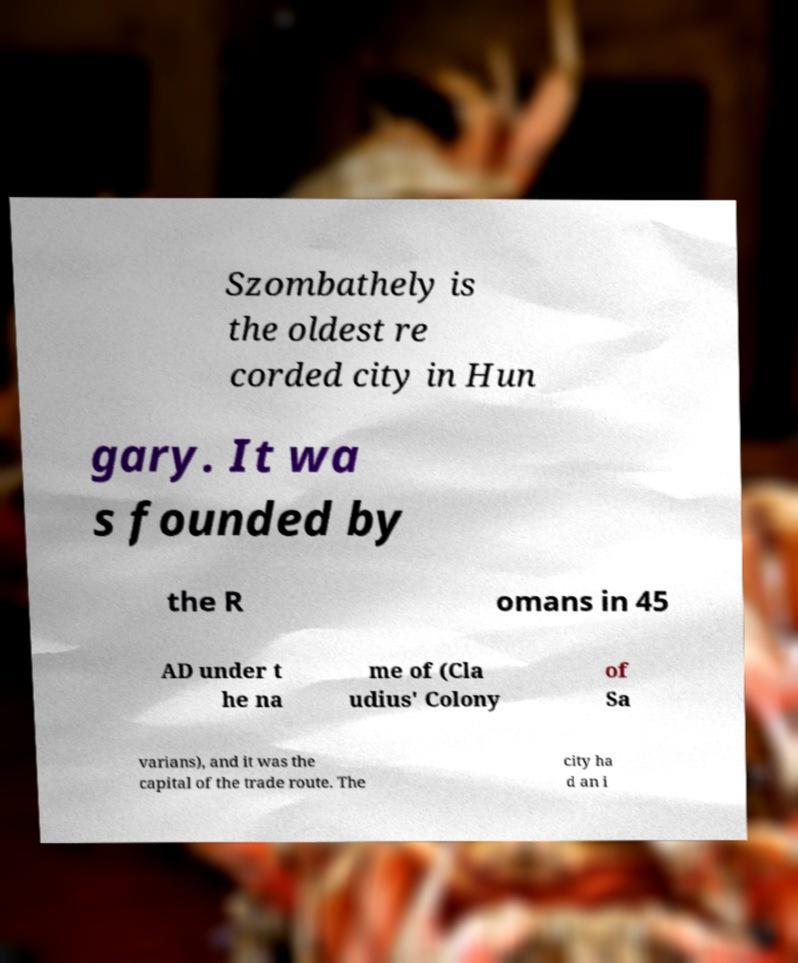Please read and relay the text visible in this image. What does it say? Szombathely is the oldest re corded city in Hun gary. It wa s founded by the R omans in 45 AD under t he na me of (Cla udius' Colony of Sa varians), and it was the capital of the trade route. The city ha d an i 